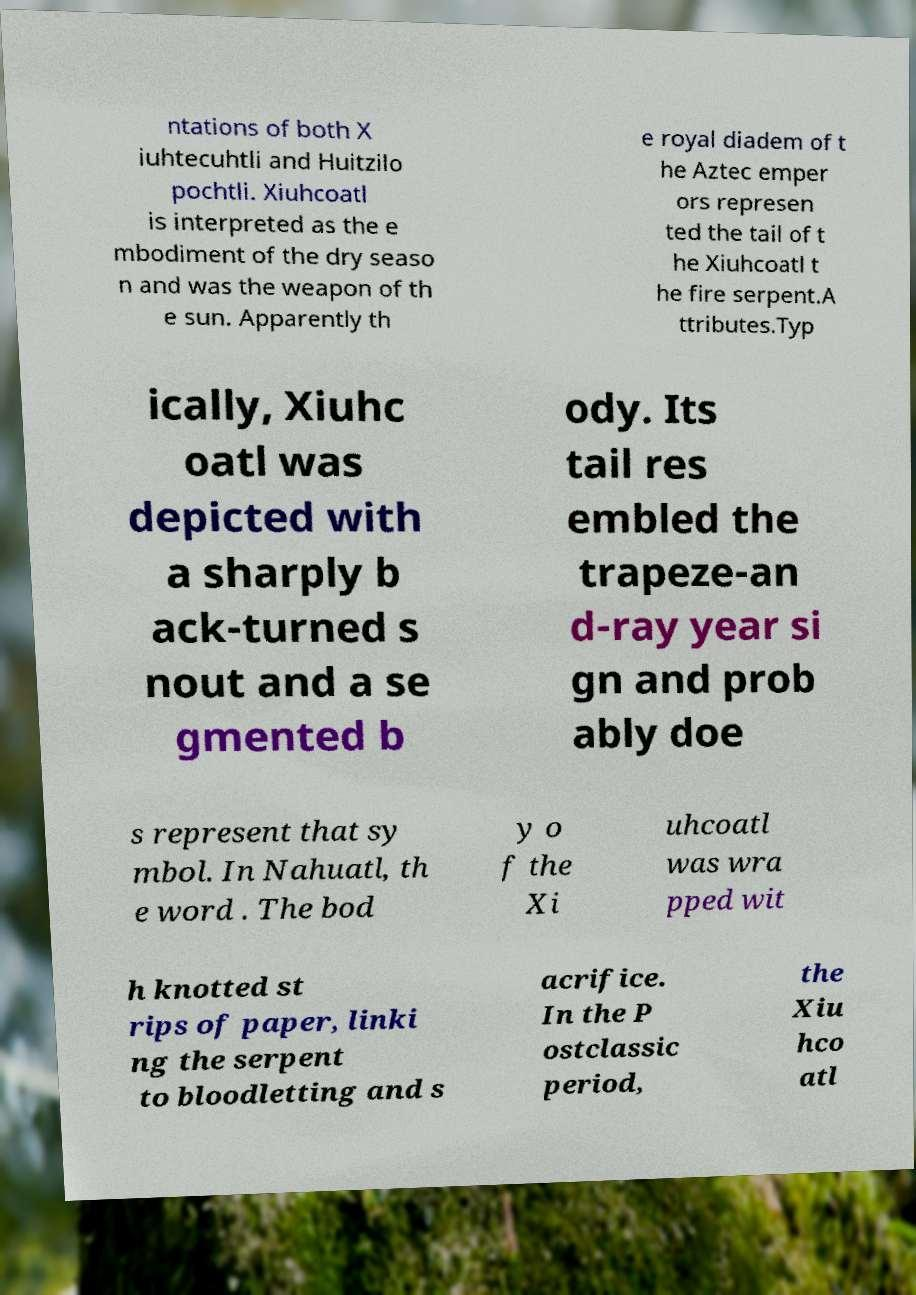What messages or text are displayed in this image? I need them in a readable, typed format. ntations of both X iuhtecuhtli and Huitzilo pochtli. Xiuhcoatl is interpreted as the e mbodiment of the dry seaso n and was the weapon of th e sun. Apparently th e royal diadem of t he Aztec emper ors represen ted the tail of t he Xiuhcoatl t he fire serpent.A ttributes.Typ ically, Xiuhc oatl was depicted with a sharply b ack-turned s nout and a se gmented b ody. Its tail res embled the trapeze-an d-ray year si gn and prob ably doe s represent that sy mbol. In Nahuatl, th e word . The bod y o f the Xi uhcoatl was wra pped wit h knotted st rips of paper, linki ng the serpent to bloodletting and s acrifice. In the P ostclassic period, the Xiu hco atl 